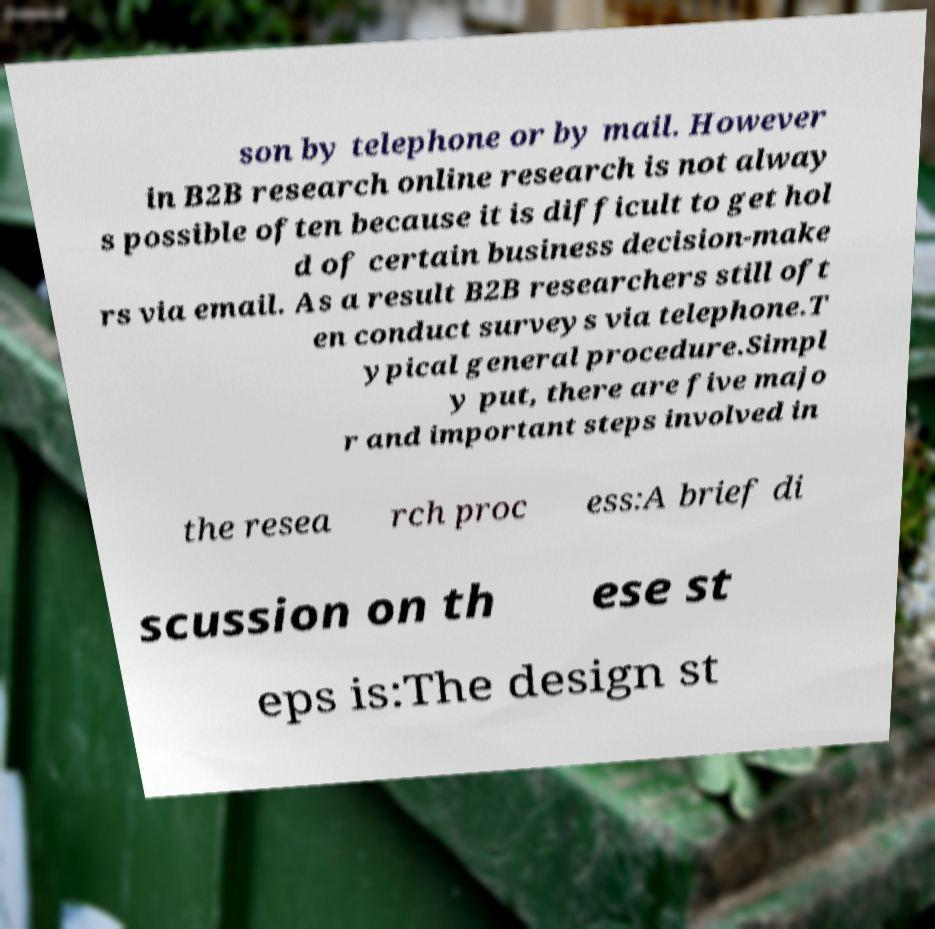Can you read and provide the text displayed in the image?This photo seems to have some interesting text. Can you extract and type it out for me? son by telephone or by mail. However in B2B research online research is not alway s possible often because it is difficult to get hol d of certain business decision-make rs via email. As a result B2B researchers still oft en conduct surveys via telephone.T ypical general procedure.Simpl y put, there are five majo r and important steps involved in the resea rch proc ess:A brief di scussion on th ese st eps is:The design st 